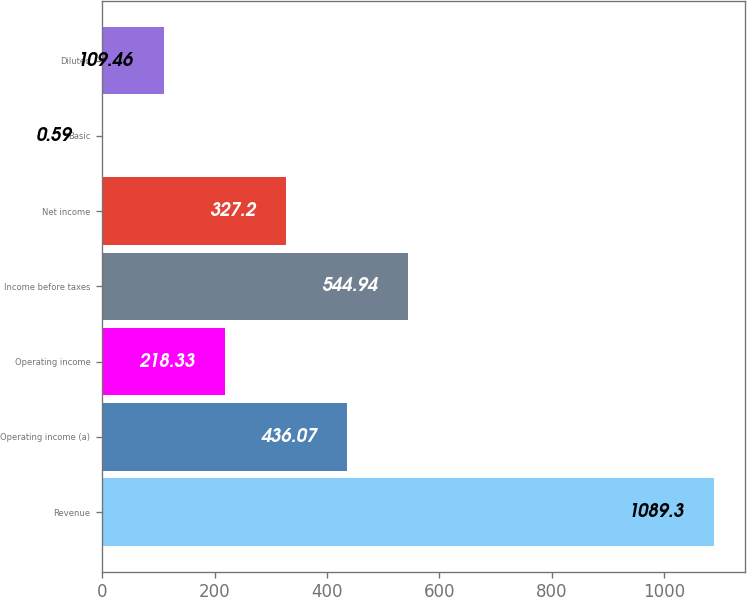Convert chart. <chart><loc_0><loc_0><loc_500><loc_500><bar_chart><fcel>Revenue<fcel>Operating income (a)<fcel>Operating income<fcel>Income before taxes<fcel>Net income<fcel>Basic<fcel>Diluted<nl><fcel>1089.3<fcel>436.07<fcel>218.33<fcel>544.94<fcel>327.2<fcel>0.59<fcel>109.46<nl></chart> 